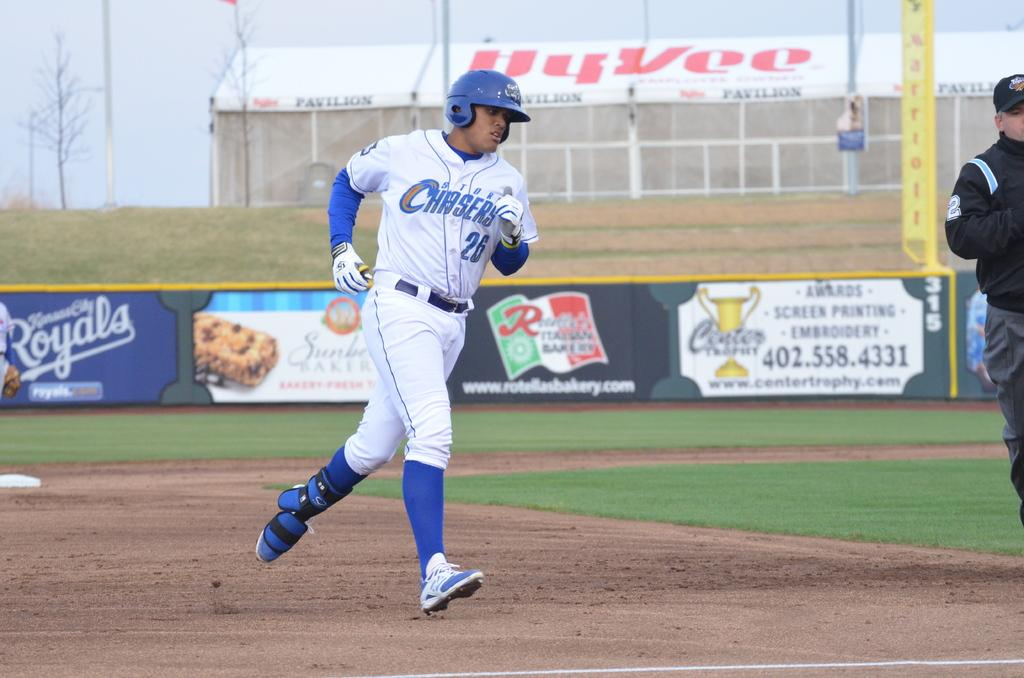<image>
Summarize the visual content of the image. A baseball player in a Chasers uniform rounds the bases. 